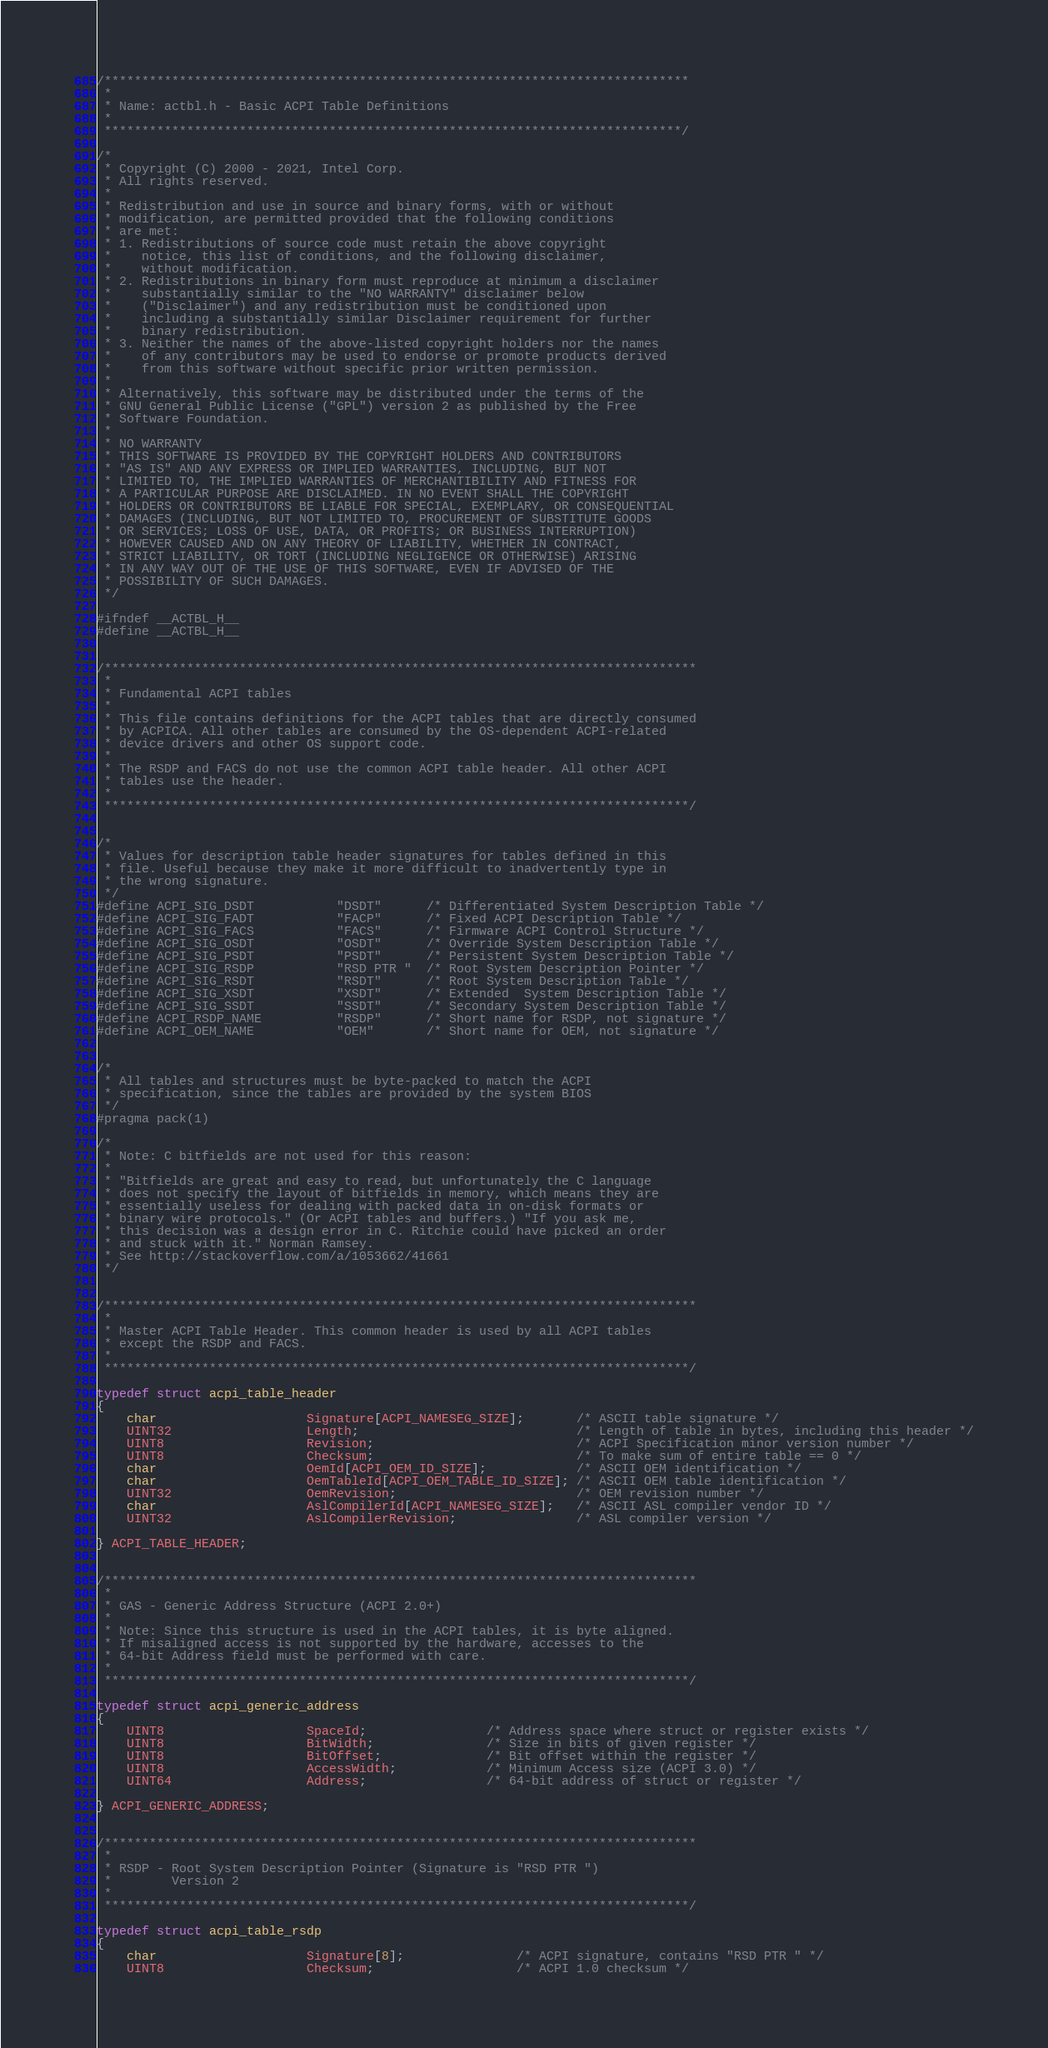Convert code to text. <code><loc_0><loc_0><loc_500><loc_500><_C_>/******************************************************************************
 *
 * Name: actbl.h - Basic ACPI Table Definitions
 *
 *****************************************************************************/

/*
 * Copyright (C) 2000 - 2021, Intel Corp.
 * All rights reserved.
 *
 * Redistribution and use in source and binary forms, with or without
 * modification, are permitted provided that the following conditions
 * are met:
 * 1. Redistributions of source code must retain the above copyright
 *    notice, this list of conditions, and the following disclaimer,
 *    without modification.
 * 2. Redistributions in binary form must reproduce at minimum a disclaimer
 *    substantially similar to the "NO WARRANTY" disclaimer below
 *    ("Disclaimer") and any redistribution must be conditioned upon
 *    including a substantially similar Disclaimer requirement for further
 *    binary redistribution.
 * 3. Neither the names of the above-listed copyright holders nor the names
 *    of any contributors may be used to endorse or promote products derived
 *    from this software without specific prior written permission.
 *
 * Alternatively, this software may be distributed under the terms of the
 * GNU General Public License ("GPL") version 2 as published by the Free
 * Software Foundation.
 *
 * NO WARRANTY
 * THIS SOFTWARE IS PROVIDED BY THE COPYRIGHT HOLDERS AND CONTRIBUTORS
 * "AS IS" AND ANY EXPRESS OR IMPLIED WARRANTIES, INCLUDING, BUT NOT
 * LIMITED TO, THE IMPLIED WARRANTIES OF MERCHANTIBILITY AND FITNESS FOR
 * A PARTICULAR PURPOSE ARE DISCLAIMED. IN NO EVENT SHALL THE COPYRIGHT
 * HOLDERS OR CONTRIBUTORS BE LIABLE FOR SPECIAL, EXEMPLARY, OR CONSEQUENTIAL
 * DAMAGES (INCLUDING, BUT NOT LIMITED TO, PROCUREMENT OF SUBSTITUTE GOODS
 * OR SERVICES; LOSS OF USE, DATA, OR PROFITS; OR BUSINESS INTERRUPTION)
 * HOWEVER CAUSED AND ON ANY THEORY OF LIABILITY, WHETHER IN CONTRACT,
 * STRICT LIABILITY, OR TORT (INCLUDING NEGLIGENCE OR OTHERWISE) ARISING
 * IN ANY WAY OUT OF THE USE OF THIS SOFTWARE, EVEN IF ADVISED OF THE
 * POSSIBILITY OF SUCH DAMAGES.
 */

#ifndef __ACTBL_H__
#define __ACTBL_H__


/*******************************************************************************
 *
 * Fundamental ACPI tables
 *
 * This file contains definitions for the ACPI tables that are directly consumed
 * by ACPICA. All other tables are consumed by the OS-dependent ACPI-related
 * device drivers and other OS support code.
 *
 * The RSDP and FACS do not use the common ACPI table header. All other ACPI
 * tables use the header.
 *
 ******************************************************************************/


/*
 * Values for description table header signatures for tables defined in this
 * file. Useful because they make it more difficult to inadvertently type in
 * the wrong signature.
 */
#define ACPI_SIG_DSDT           "DSDT"      /* Differentiated System Description Table */
#define ACPI_SIG_FADT           "FACP"      /* Fixed ACPI Description Table */
#define ACPI_SIG_FACS           "FACS"      /* Firmware ACPI Control Structure */
#define ACPI_SIG_OSDT           "OSDT"      /* Override System Description Table */
#define ACPI_SIG_PSDT           "PSDT"      /* Persistent System Description Table */
#define ACPI_SIG_RSDP           "RSD PTR "  /* Root System Description Pointer */
#define ACPI_SIG_RSDT           "RSDT"      /* Root System Description Table */
#define ACPI_SIG_XSDT           "XSDT"      /* Extended  System Description Table */
#define ACPI_SIG_SSDT           "SSDT"      /* Secondary System Description Table */
#define ACPI_RSDP_NAME          "RSDP"      /* Short name for RSDP, not signature */
#define ACPI_OEM_NAME           "OEM"       /* Short name for OEM, not signature */


/*
 * All tables and structures must be byte-packed to match the ACPI
 * specification, since the tables are provided by the system BIOS
 */
#pragma pack(1)

/*
 * Note: C bitfields are not used for this reason:
 *
 * "Bitfields are great and easy to read, but unfortunately the C language
 * does not specify the layout of bitfields in memory, which means they are
 * essentially useless for dealing with packed data in on-disk formats or
 * binary wire protocols." (Or ACPI tables and buffers.) "If you ask me,
 * this decision was a design error in C. Ritchie could have picked an order
 * and stuck with it." Norman Ramsey.
 * See http://stackoverflow.com/a/1053662/41661
 */


/*******************************************************************************
 *
 * Master ACPI Table Header. This common header is used by all ACPI tables
 * except the RSDP and FACS.
 *
 ******************************************************************************/

typedef struct acpi_table_header
{
    char                    Signature[ACPI_NAMESEG_SIZE];       /* ASCII table signature */
    UINT32                  Length;                             /* Length of table in bytes, including this header */
    UINT8                   Revision;                           /* ACPI Specification minor version number */
    UINT8                   Checksum;                           /* To make sum of entire table == 0 */
    char                    OemId[ACPI_OEM_ID_SIZE];            /* ASCII OEM identification */
    char                    OemTableId[ACPI_OEM_TABLE_ID_SIZE]; /* ASCII OEM table identification */
    UINT32                  OemRevision;                        /* OEM revision number */
    char                    AslCompilerId[ACPI_NAMESEG_SIZE];   /* ASCII ASL compiler vendor ID */
    UINT32                  AslCompilerRevision;                /* ASL compiler version */

} ACPI_TABLE_HEADER;


/*******************************************************************************
 *
 * GAS - Generic Address Structure (ACPI 2.0+)
 *
 * Note: Since this structure is used in the ACPI tables, it is byte aligned.
 * If misaligned access is not supported by the hardware, accesses to the
 * 64-bit Address field must be performed with care.
 *
 ******************************************************************************/

typedef struct acpi_generic_address
{
    UINT8                   SpaceId;                /* Address space where struct or register exists */
    UINT8                   BitWidth;               /* Size in bits of given register */
    UINT8                   BitOffset;              /* Bit offset within the register */
    UINT8                   AccessWidth;            /* Minimum Access size (ACPI 3.0) */
    UINT64                  Address;                /* 64-bit address of struct or register */

} ACPI_GENERIC_ADDRESS;


/*******************************************************************************
 *
 * RSDP - Root System Description Pointer (Signature is "RSD PTR ")
 *        Version 2
 *
 ******************************************************************************/

typedef struct acpi_table_rsdp
{
    char                    Signature[8];               /* ACPI signature, contains "RSD PTR " */
    UINT8                   Checksum;                   /* ACPI 1.0 checksum */</code> 